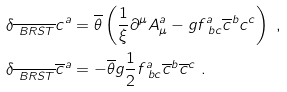<formula> <loc_0><loc_0><loc_500><loc_500>& \delta _ { \overline { \ B R S T } } c ^ { a } = \overline { \theta } \left ( \frac { 1 } { \xi } \partial ^ { \mu } A ^ { a } _ { \mu } - g f ^ { a } _ { \ b c } \overline { c } ^ { b } c ^ { c } \right ) \ , \\ & \delta _ { \overline { \ B R S T } } \overline { c } ^ { a } = - \overline { \theta } g \frac { 1 } { 2 } f ^ { a } _ { \ b c } \overline { c } ^ { b } \overline { c } ^ { c } \ .</formula> 